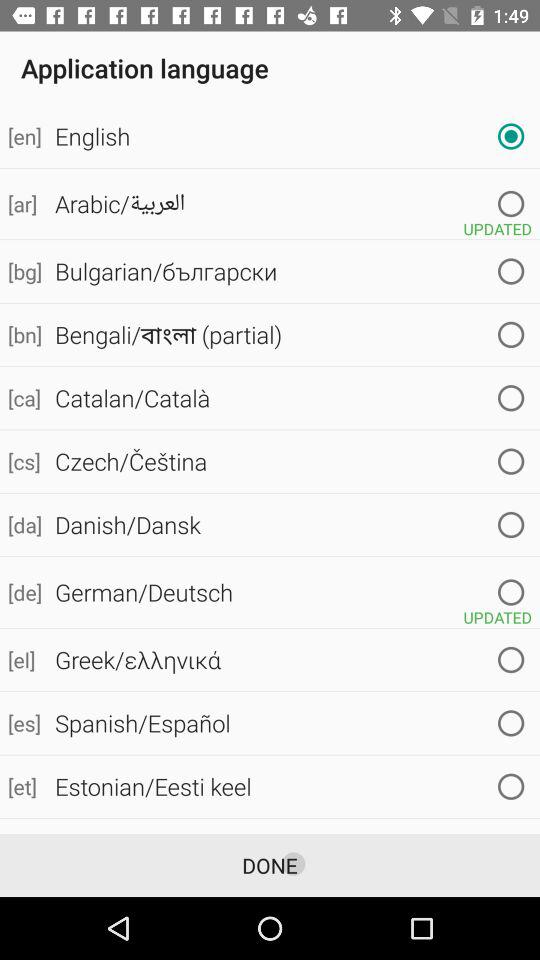What is the full form of the EULA? The full form of the EULA is the End User License Agreement. 